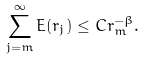Convert formula to latex. <formula><loc_0><loc_0><loc_500><loc_500>\sum _ { j = m } ^ { \infty } E ( r _ { j } ) \leq C r _ { m } ^ { - \beta } .</formula> 